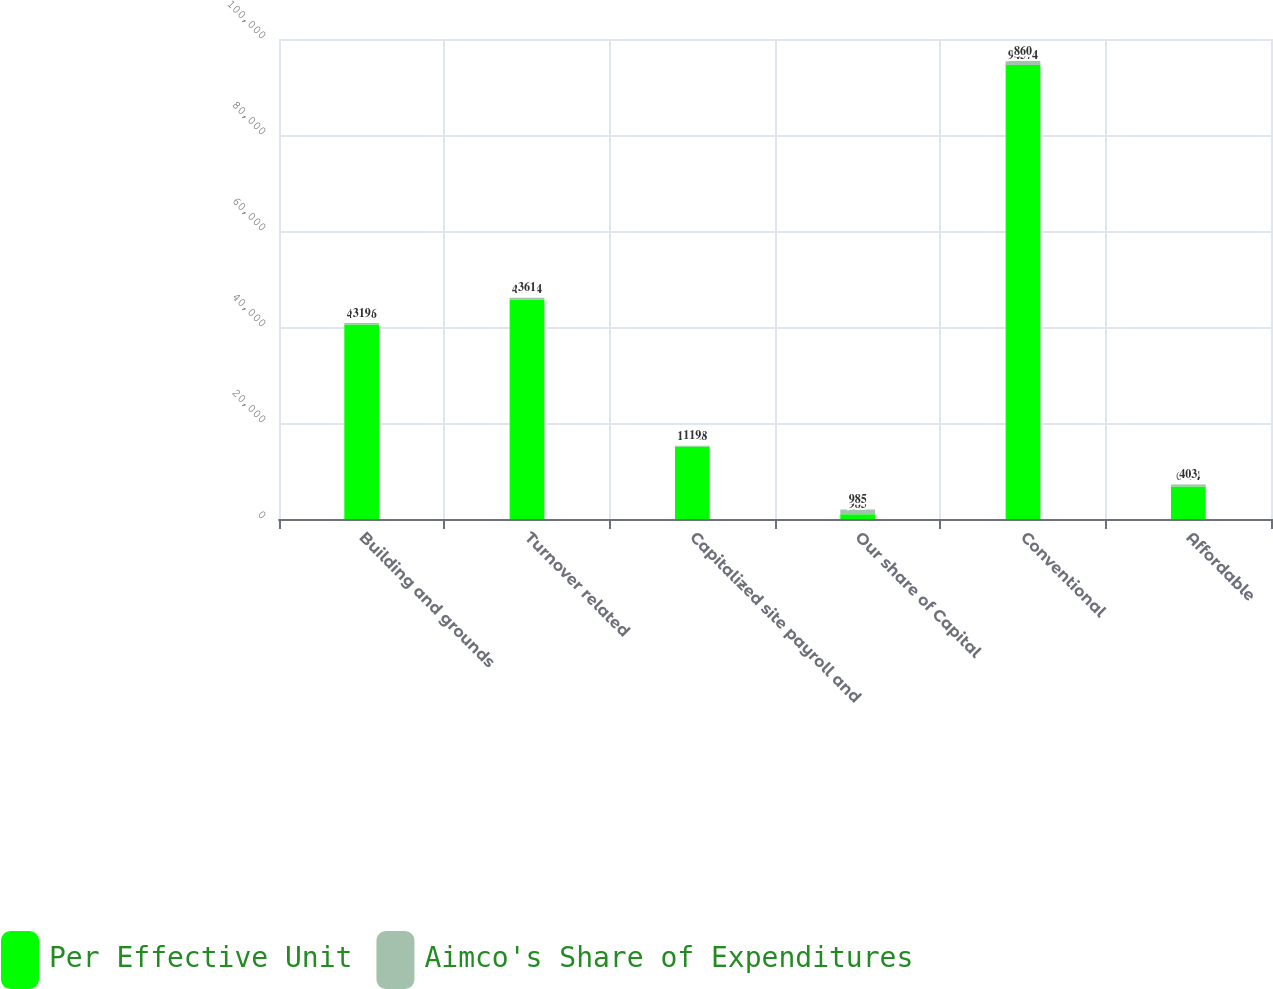Convert chart. <chart><loc_0><loc_0><loc_500><loc_500><stacked_bar_chart><ecel><fcel>Building and grounds<fcel>Turnover related<fcel>Capitalized site payroll and<fcel>Our share of Capital<fcel>Conventional<fcel>Affordable<nl><fcel>Per Effective Unit<fcel>40516<fcel>45724<fcel>15128<fcel>985<fcel>94574<fcel>6794<nl><fcel>Aimco's Share of Expenditures<fcel>319<fcel>361<fcel>119<fcel>985<fcel>860<fcel>403<nl></chart> 